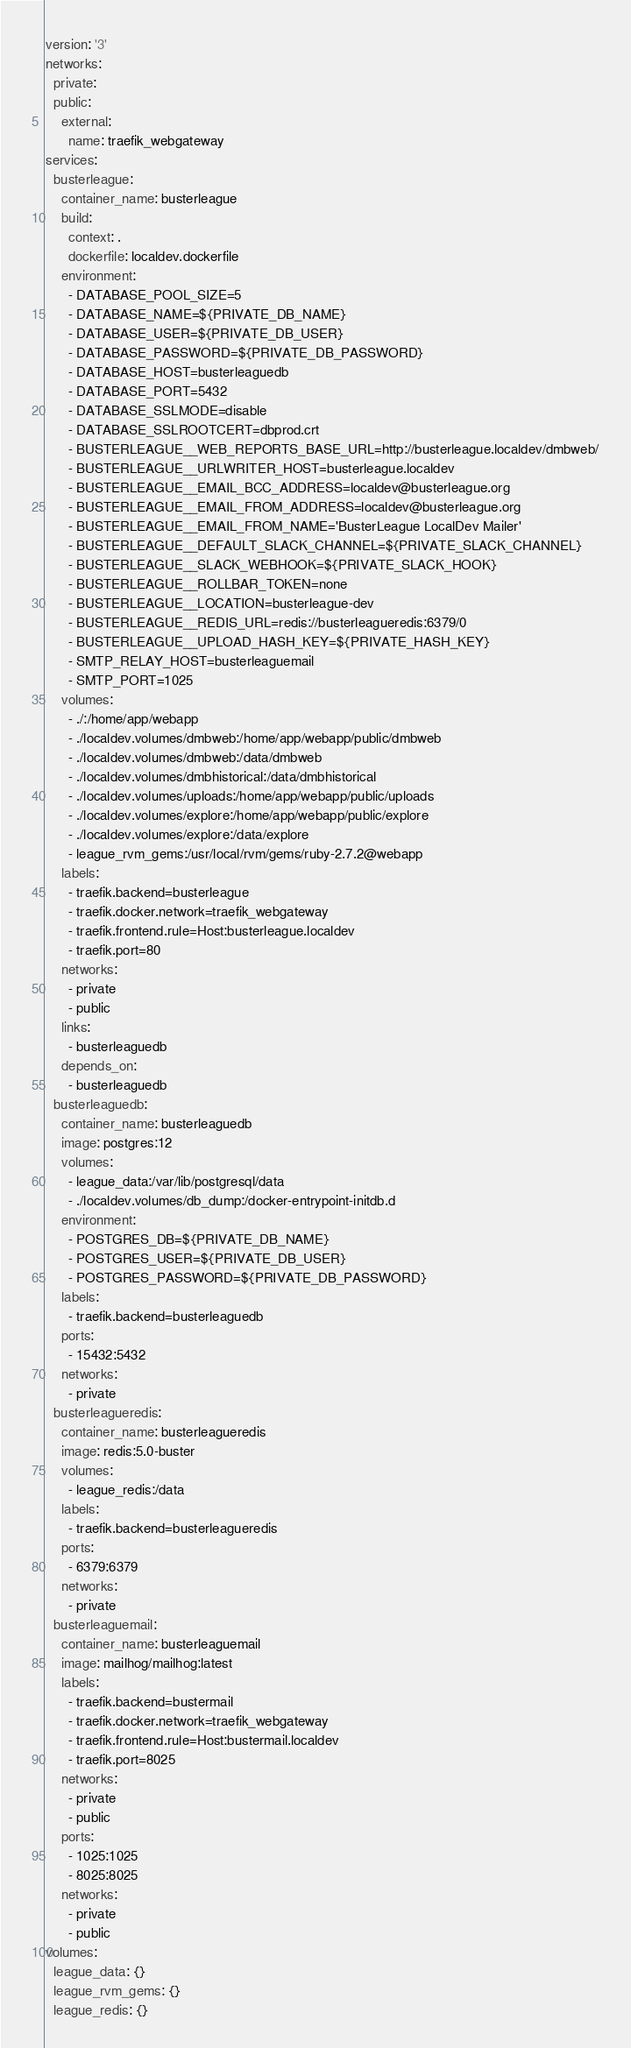Convert code to text. <code><loc_0><loc_0><loc_500><loc_500><_YAML_>version: '3'
networks:
  private:
  public:
    external:
      name: traefik_webgateway
services:
  busterleague:
    container_name: busterleague
    build:
      context: .
      dockerfile: localdev.dockerfile
    environment:
      - DATABASE_POOL_SIZE=5
      - DATABASE_NAME=${PRIVATE_DB_NAME}
      - DATABASE_USER=${PRIVATE_DB_USER}
      - DATABASE_PASSWORD=${PRIVATE_DB_PASSWORD}
      - DATABASE_HOST=busterleaguedb
      - DATABASE_PORT=5432
      - DATABASE_SSLMODE=disable
      - DATABASE_SSLROOTCERT=dbprod.crt
      - BUSTERLEAGUE__WEB_REPORTS_BASE_URL=http://busterleague.localdev/dmbweb/
      - BUSTERLEAGUE__URLWRITER_HOST=busterleague.localdev
      - BUSTERLEAGUE__EMAIL_BCC_ADDRESS=localdev@busterleague.org
      - BUSTERLEAGUE__EMAIL_FROM_ADDRESS=localdev@busterleague.org
      - BUSTERLEAGUE__EMAIL_FROM_NAME='BusterLeague LocalDev Mailer'
      - BUSTERLEAGUE__DEFAULT_SLACK_CHANNEL=${PRIVATE_SLACK_CHANNEL}
      - BUSTERLEAGUE__SLACK_WEBHOOK=${PRIVATE_SLACK_HOOK}
      - BUSTERLEAGUE__ROLLBAR_TOKEN=none
      - BUSTERLEAGUE__LOCATION=busterleague-dev
      - BUSTERLEAGUE__REDIS_URL=redis://busterleagueredis:6379/0
      - BUSTERLEAGUE__UPLOAD_HASH_KEY=${PRIVATE_HASH_KEY}
      - SMTP_RELAY_HOST=busterleaguemail
      - SMTP_PORT=1025
    volumes:
      - ./:/home/app/webapp
      - ./localdev.volumes/dmbweb:/home/app/webapp/public/dmbweb
      - ./localdev.volumes/dmbweb:/data/dmbweb
      - ./localdev.volumes/dmbhistorical:/data/dmbhistorical
      - ./localdev.volumes/uploads:/home/app/webapp/public/uploads
      - ./localdev.volumes/explore:/home/app/webapp/public/explore
      - ./localdev.volumes/explore:/data/explore
      - league_rvm_gems:/usr/local/rvm/gems/ruby-2.7.2@webapp
    labels:
      - traefik.backend=busterleague
      - traefik.docker.network=traefik_webgateway
      - traefik.frontend.rule=Host:busterleague.localdev
      - traefik.port=80
    networks:
      - private
      - public
    links:
      - busterleaguedb
    depends_on:
      - busterleaguedb
  busterleaguedb:
    container_name: busterleaguedb
    image: postgres:12
    volumes:
      - league_data:/var/lib/postgresql/data
      - ./localdev.volumes/db_dump:/docker-entrypoint-initdb.d
    environment:
      - POSTGRES_DB=${PRIVATE_DB_NAME}
      - POSTGRES_USER=${PRIVATE_DB_USER}
      - POSTGRES_PASSWORD=${PRIVATE_DB_PASSWORD}
    labels:
      - traefik.backend=busterleaguedb
    ports:
      - 15432:5432
    networks:
      - private
  busterleagueredis:
    container_name: busterleagueredis
    image: redis:5.0-buster
    volumes:
      - league_redis:/data
    labels:
      - traefik.backend=busterleagueredis
    ports:
      - 6379:6379
    networks:
      - private
  busterleaguemail:
    container_name: busterleaguemail
    image: mailhog/mailhog:latest
    labels:
      - traefik.backend=bustermail
      - traefik.docker.network=traefik_webgateway
      - traefik.frontend.rule=Host:bustermail.localdev
      - traefik.port=8025
    networks:
      - private
      - public
    ports:
      - 1025:1025
      - 8025:8025
    networks:
      - private
      - public
volumes:
  league_data: {}
  league_rvm_gems: {}
  league_redis: {}</code> 